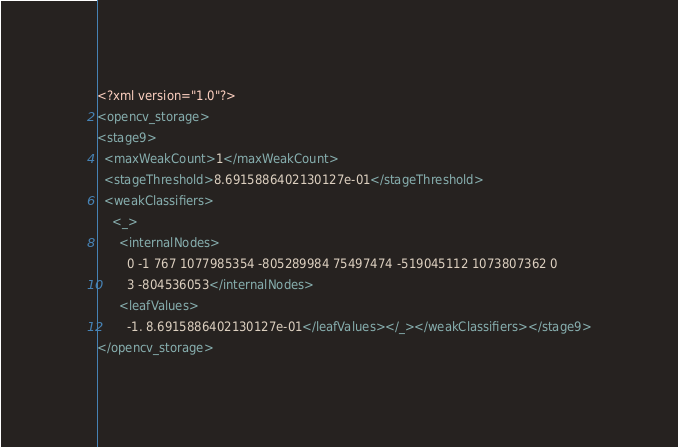<code> <loc_0><loc_0><loc_500><loc_500><_XML_><?xml version="1.0"?>
<opencv_storage>
<stage9>
  <maxWeakCount>1</maxWeakCount>
  <stageThreshold>8.6915886402130127e-01</stageThreshold>
  <weakClassifiers>
    <_>
      <internalNodes>
        0 -1 767 1077985354 -805289984 75497474 -519045112 1073807362 0
        3 -804536053</internalNodes>
      <leafValues>
        -1. 8.6915886402130127e-01</leafValues></_></weakClassifiers></stage9>
</opencv_storage>
</code> 